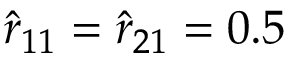Convert formula to latex. <formula><loc_0><loc_0><loc_500><loc_500>\hat { r } _ { 1 1 } = \hat { r } _ { 2 1 } = 0 . 5</formula> 